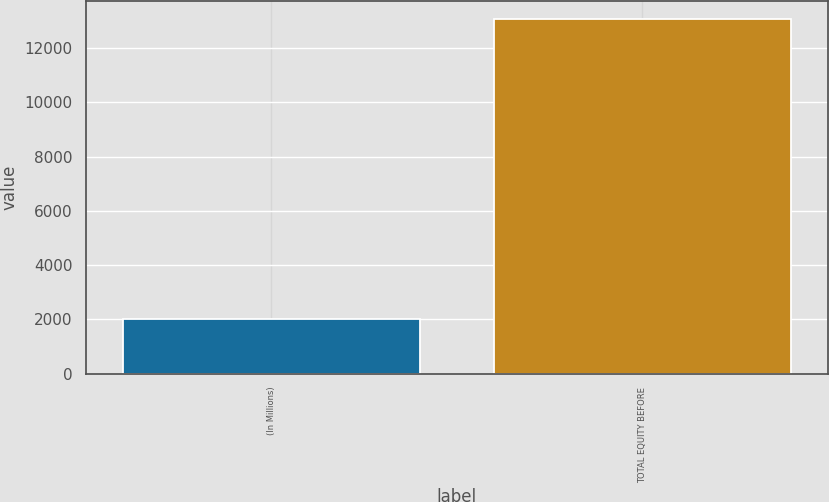<chart> <loc_0><loc_0><loc_500><loc_500><bar_chart><fcel>(In Millions)<fcel>TOTAL EQUITY BEFORE<nl><fcel>2015<fcel>13086<nl></chart> 